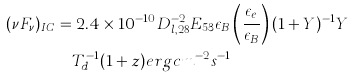Convert formula to latex. <formula><loc_0><loc_0><loc_500><loc_500>( \nu F _ { \nu } ) _ { I C } & = 2 . 4 \times 1 0 ^ { - 1 0 } D _ { l , 2 8 } ^ { - 2 } E _ { 5 3 } \epsilon _ { B } \left ( \frac { \epsilon _ { e } } { \epsilon _ { B } } \right ) ( 1 + Y ) ^ { - 1 } Y \\ & \quad T _ { d } ^ { - 1 } ( 1 + z ) e r g c m ^ { - 2 } s ^ { - 1 }</formula> 